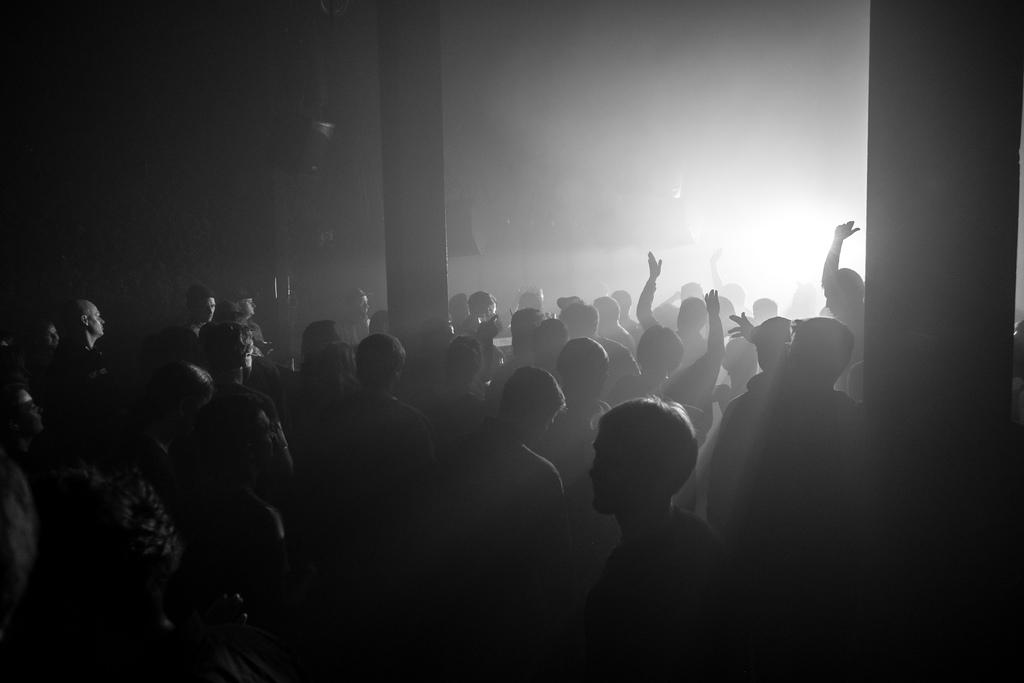What is the main subject of the image? The main subject of the image is a group of people. What are the people in the image doing? The people are standing. What other object can be seen in the image? There is a pillar in the image. How would you describe the lighting in the image? The image has a dark setting. What type of art is displayed on the pillar in the image? There is no art displayed on the pillar in the image; it is a plain pillar. Can you tell me how many quinces are present in the image? There are no quinces present in the image. 